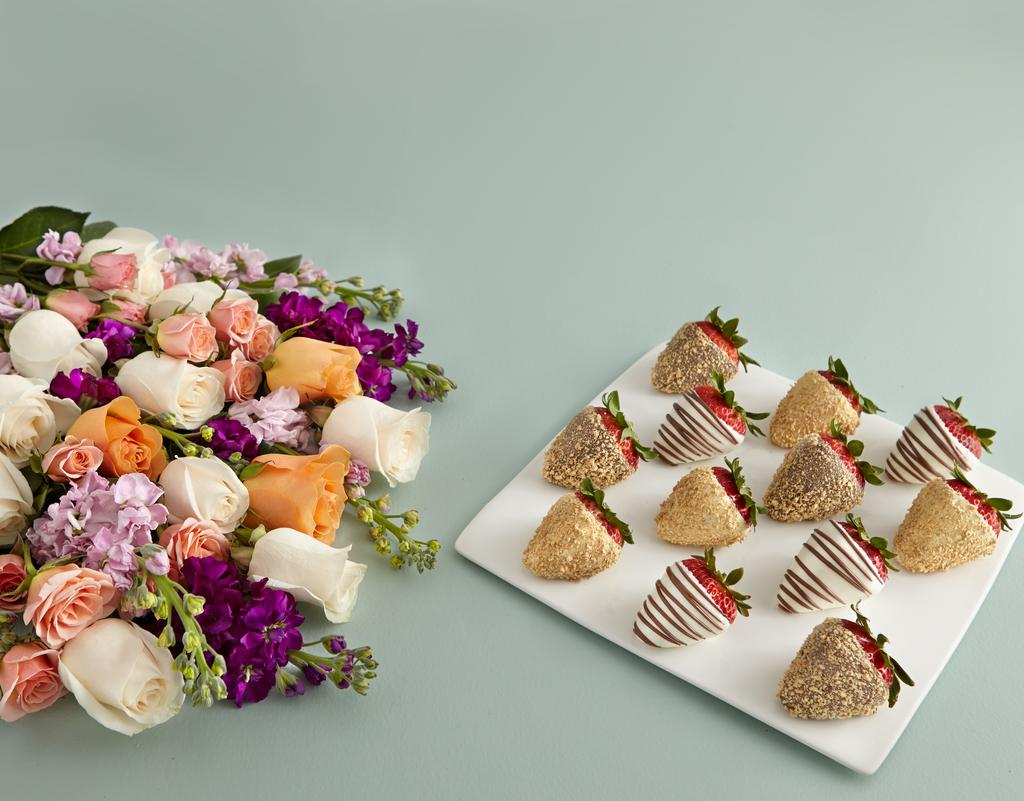What can be seen on the left side of the image? There are different colors of flowers on a platform on the left side of the image. What is located on the right side of the image? There are strawberries with some designs on a plate on a platform on the right side of the image. Where is the zebra taking a recess in the image? There is no zebra present in the image, so it cannot be taking a recess. 